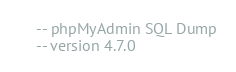Convert code to text. <code><loc_0><loc_0><loc_500><loc_500><_SQL_>-- phpMyAdmin SQL Dump
-- version 4.7.0</code> 